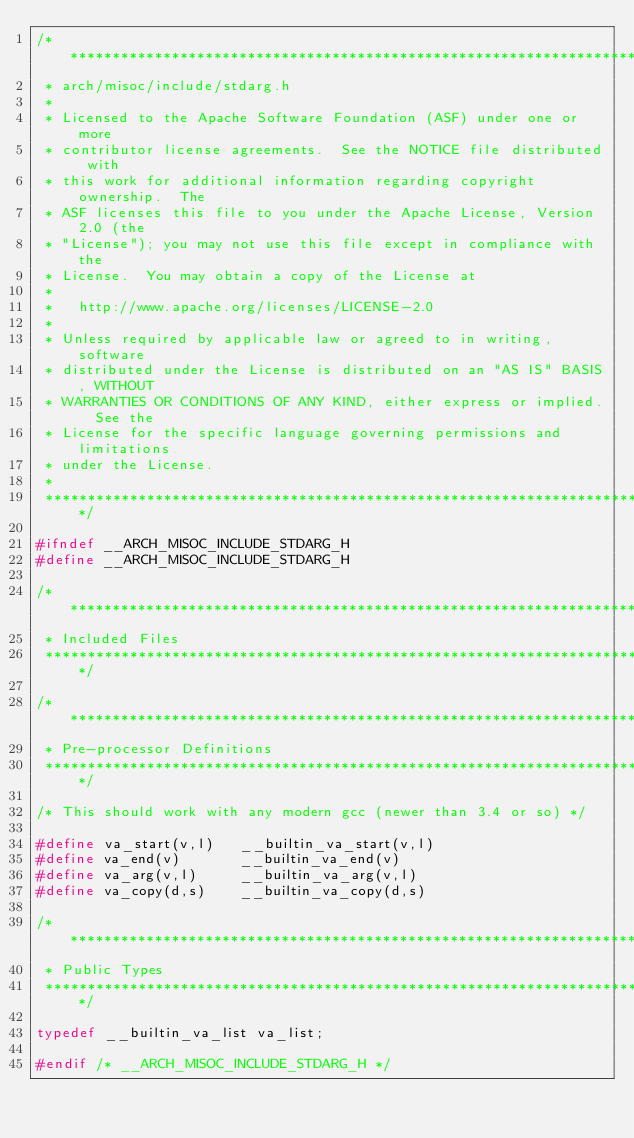<code> <loc_0><loc_0><loc_500><loc_500><_C_>/****************************************************************************
 * arch/misoc/include/stdarg.h
 *
 * Licensed to the Apache Software Foundation (ASF) under one or more
 * contributor license agreements.  See the NOTICE file distributed with
 * this work for additional information regarding copyright ownership.  The
 * ASF licenses this file to you under the Apache License, Version 2.0 (the
 * "License"); you may not use this file except in compliance with the
 * License.  You may obtain a copy of the License at
 *
 *   http://www.apache.org/licenses/LICENSE-2.0
 *
 * Unless required by applicable law or agreed to in writing, software
 * distributed under the License is distributed on an "AS IS" BASIS, WITHOUT
 * WARRANTIES OR CONDITIONS OF ANY KIND, either express or implied.  See the
 * License for the specific language governing permissions and limitations
 * under the License.
 *
 ****************************************************************************/

#ifndef __ARCH_MISOC_INCLUDE_STDARG_H
#define __ARCH_MISOC_INCLUDE_STDARG_H

/****************************************************************************
 * Included Files
 ****************************************************************************/

/****************************************************************************
 * Pre-processor Definitions
 ****************************************************************************/

/* This should work with any modern gcc (newer than 3.4 or so) */

#define va_start(v,l)   __builtin_va_start(v,l)
#define va_end(v)       __builtin_va_end(v)
#define va_arg(v,l)     __builtin_va_arg(v,l)
#define va_copy(d,s)    __builtin_va_copy(d,s)

/****************************************************************************
 * Public Types
 ****************************************************************************/

typedef __builtin_va_list va_list;

#endif /* __ARCH_MISOC_INCLUDE_STDARG_H */
</code> 